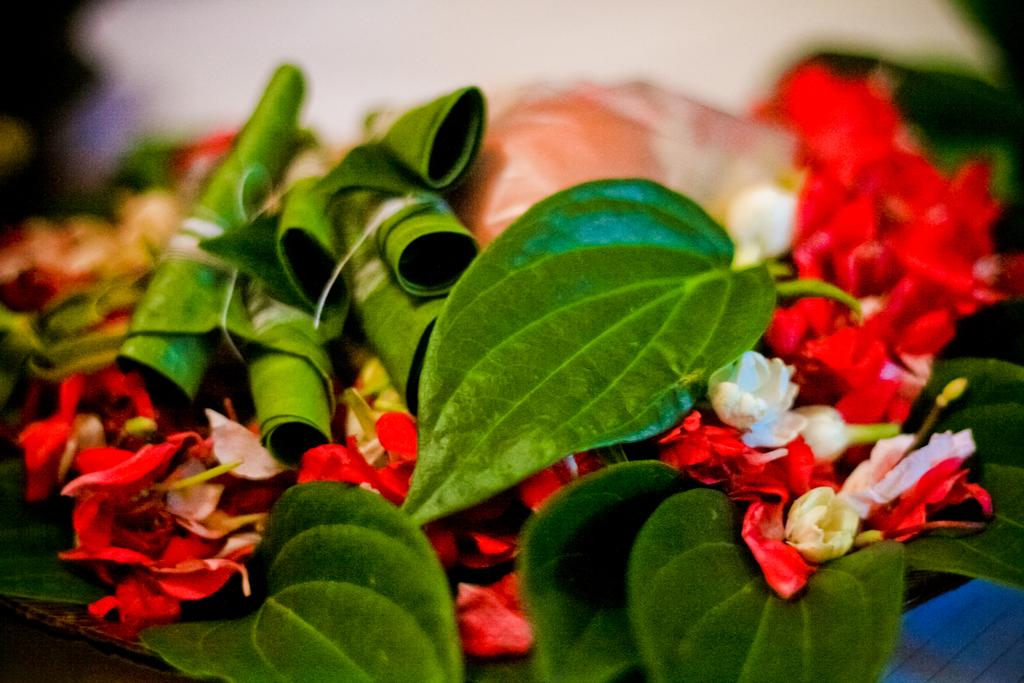What type of vegetation can be seen in the image? There are green leaves, red flowers, and white flowers in the image. Can you describe the colors of the flowers? The flowers in the image are red and white. What is the background of the image like? The background of the image is blurred. What type of note is attached to the root of the plant in the image? There is no note or root present in the image; it only features green leaves, red flowers, and white flowers with a blurred background. 